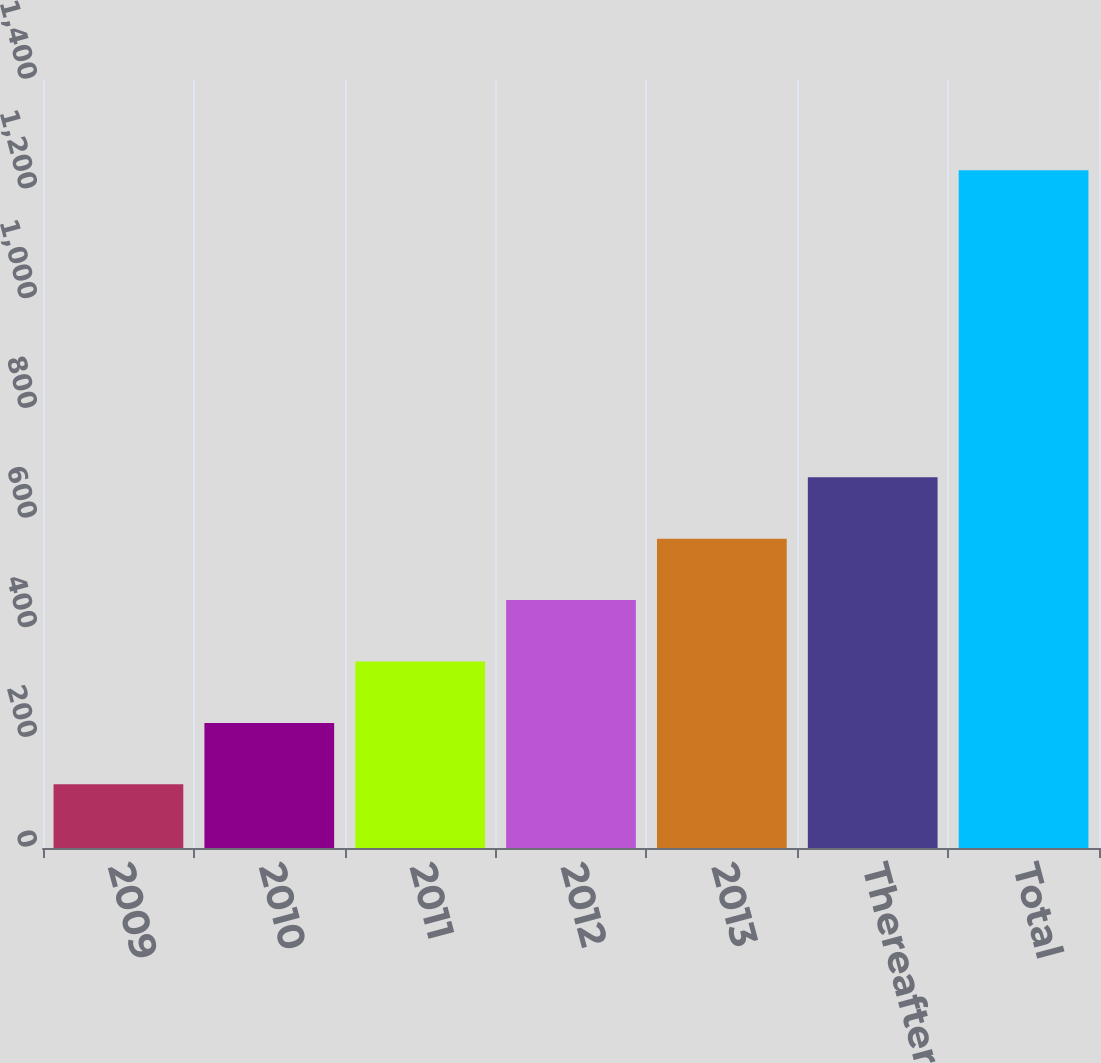Convert chart. <chart><loc_0><loc_0><loc_500><loc_500><bar_chart><fcel>2009<fcel>2010<fcel>2011<fcel>2012<fcel>2013<fcel>Thereafter<fcel>Total<nl><fcel>116<fcel>227.96<fcel>339.92<fcel>451.88<fcel>563.84<fcel>675.8<fcel>1235.6<nl></chart> 